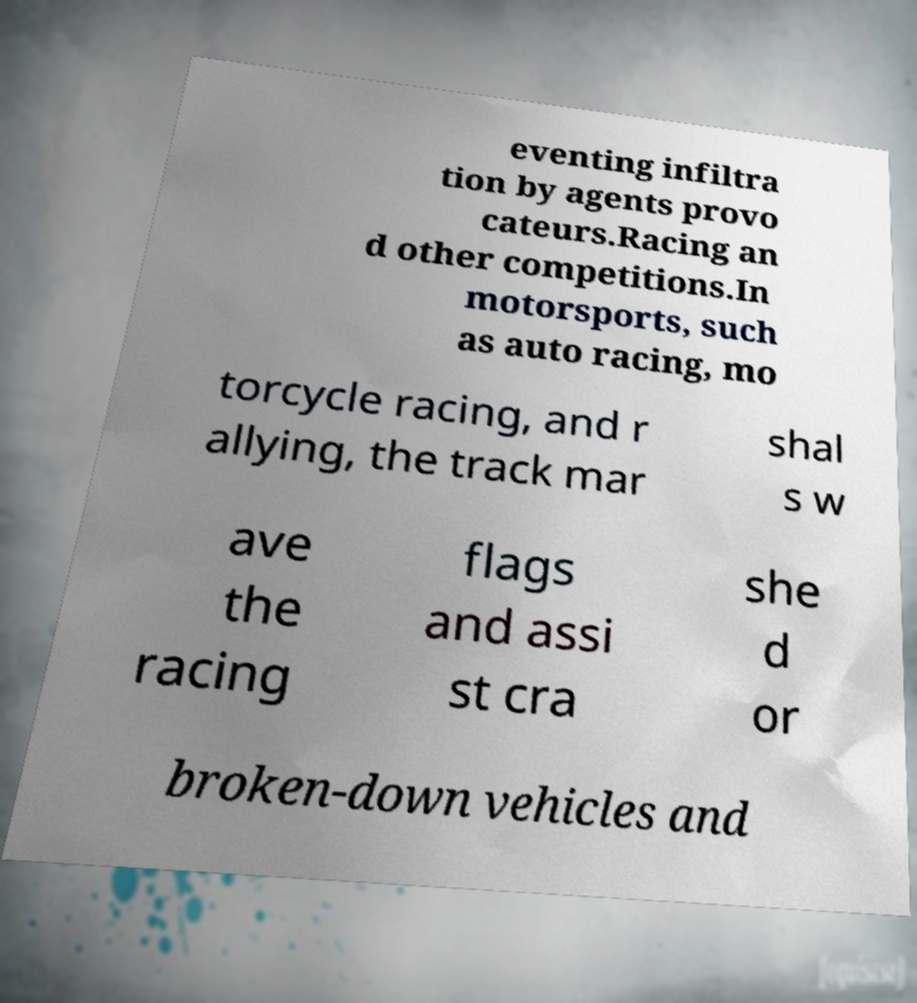Please read and relay the text visible in this image. What does it say? eventing infiltra tion by agents provo cateurs.Racing an d other competitions.In motorsports, such as auto racing, mo torcycle racing, and r allying, the track mar shal s w ave the racing flags and assi st cra she d or broken-down vehicles and 